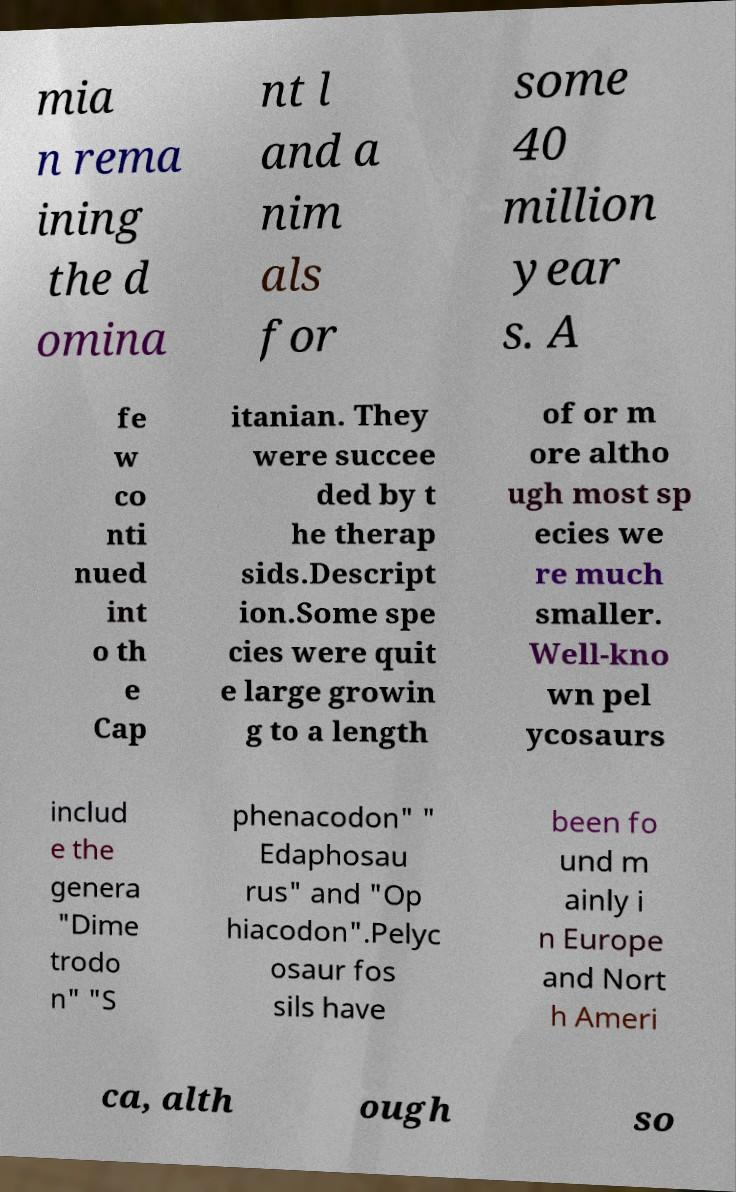For documentation purposes, I need the text within this image transcribed. Could you provide that? mia n rema ining the d omina nt l and a nim als for some 40 million year s. A fe w co nti nued int o th e Cap itanian. They were succee ded by t he therap sids.Descript ion.Some spe cies were quit e large growin g to a length of or m ore altho ugh most sp ecies we re much smaller. Well-kno wn pel ycosaurs includ e the genera "Dime trodo n" "S phenacodon" " Edaphosau rus" and "Op hiacodon".Pelyc osaur fos sils have been fo und m ainly i n Europe and Nort h Ameri ca, alth ough so 